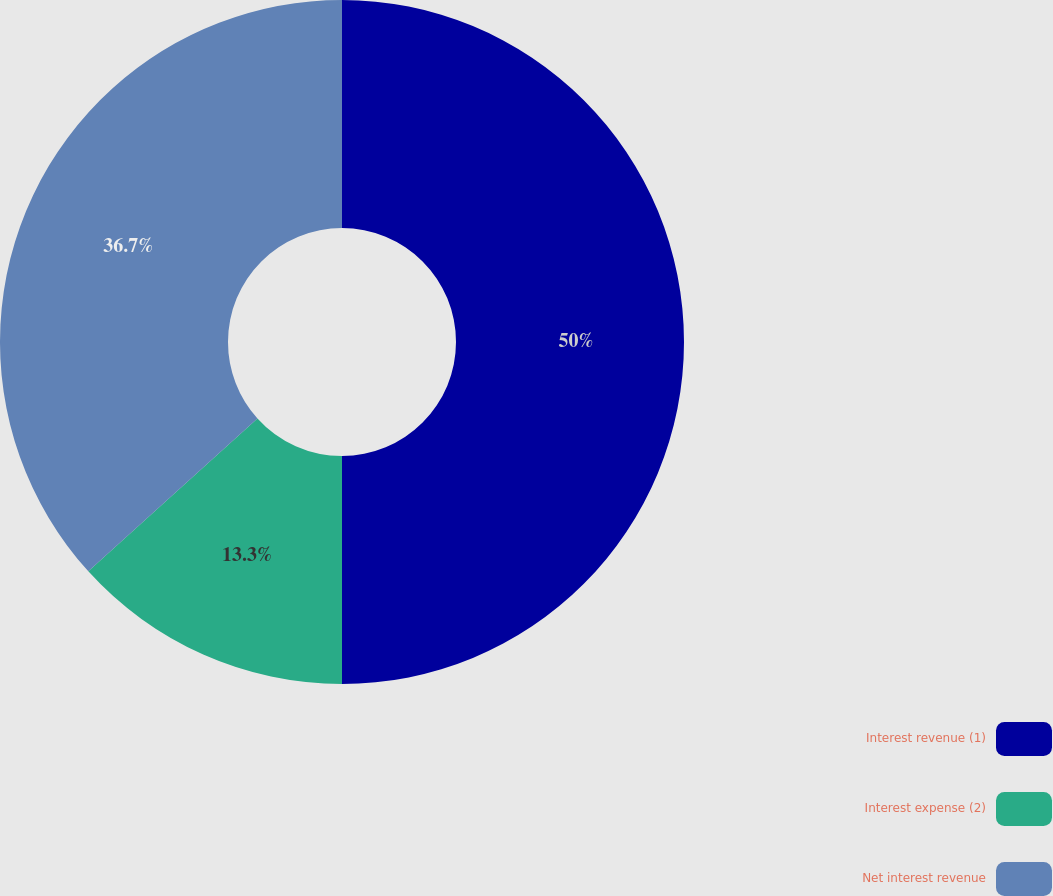<chart> <loc_0><loc_0><loc_500><loc_500><pie_chart><fcel>Interest revenue (1)<fcel>Interest expense (2)<fcel>Net interest revenue<nl><fcel>50.0%<fcel>13.3%<fcel>36.7%<nl></chart> 